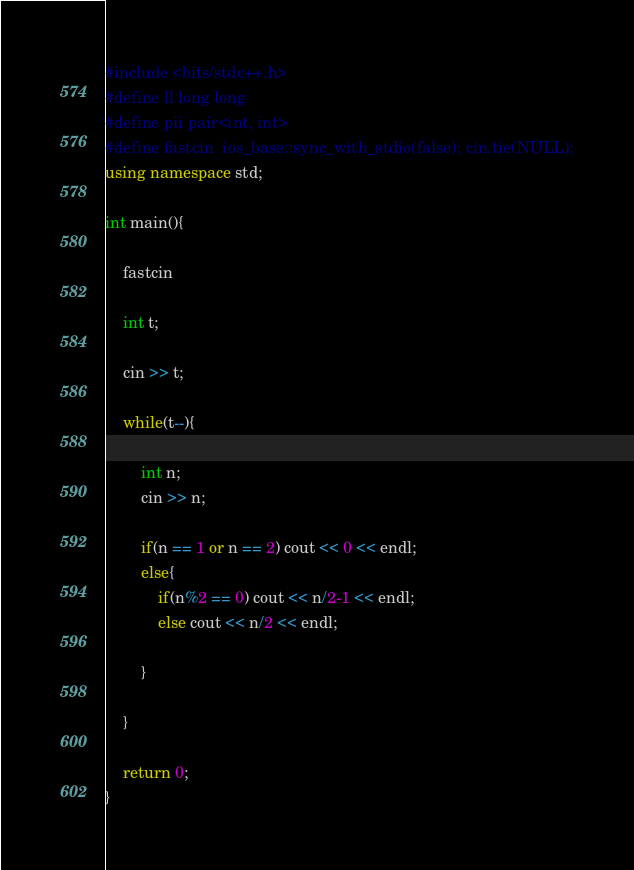<code> <loc_0><loc_0><loc_500><loc_500><_C++_>#include <bits/stdc++.h>
#define ll long long
#define pii pair<int, int>
#define fastcin  ios_base::sync_with_stdio(false); cin.tie(NULL);
using namespace std;

int main(){

	fastcin

	int t;
	
	cin >> t;
	
	while(t--){
		
		int n;
		cin >> n;
		
		if(n == 1 or n == 2) cout << 0 << endl;
		else{
			if(n%2 == 0) cout << n/2-1 << endl;
			else cout << n/2 << endl;
			
		}
		
	}

	return 0;
}
</code> 